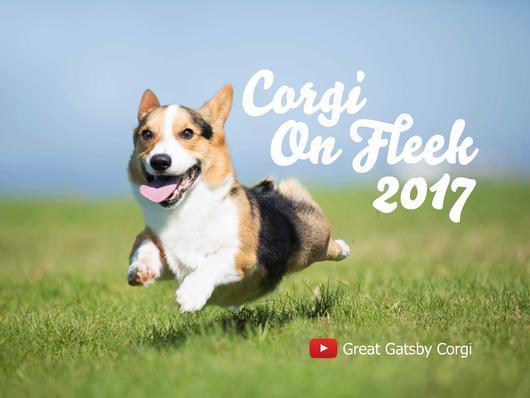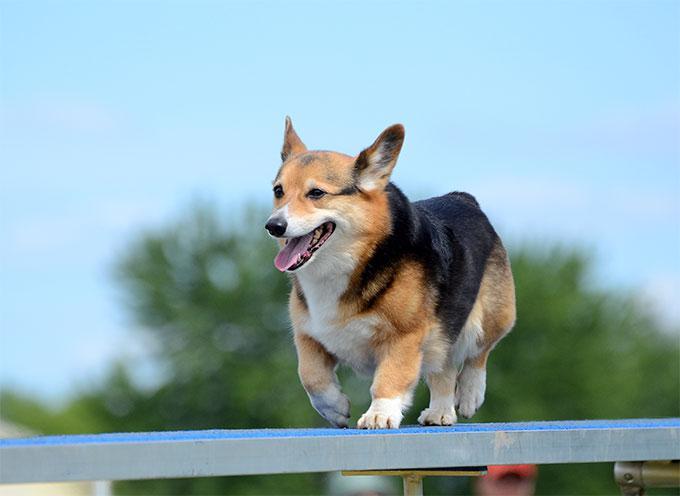The first image is the image on the left, the second image is the image on the right. For the images displayed, is the sentence "In at least one image there is  a corgi white a black belly jumping in the are with it tongue wagging" factually correct? Answer yes or no. Yes. The first image is the image on the left, the second image is the image on the right. Given the left and right images, does the statement "One dog is in snow." hold true? Answer yes or no. No. 